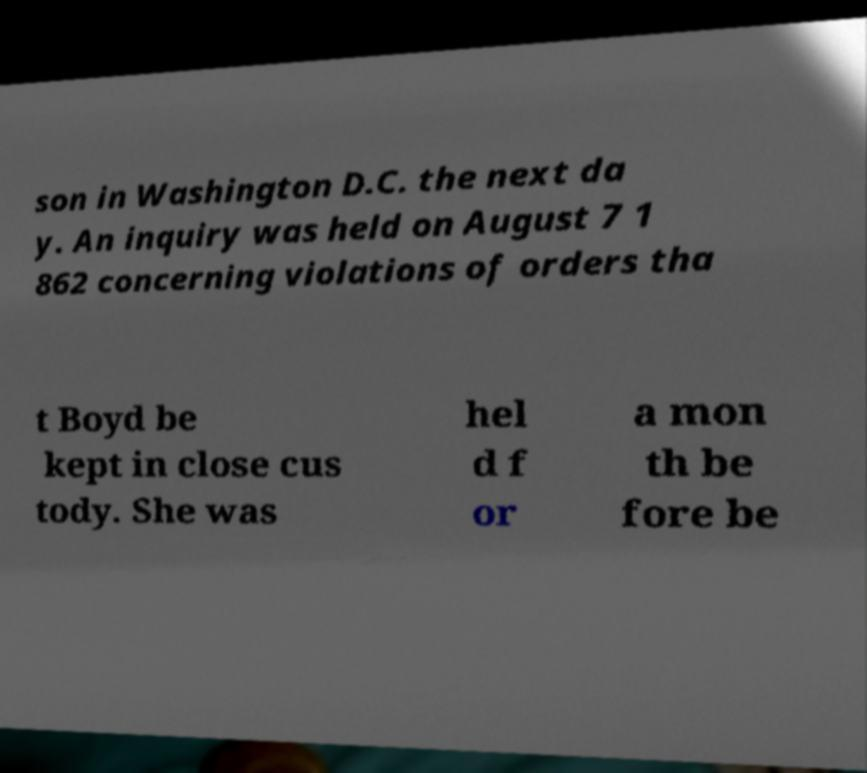There's text embedded in this image that I need extracted. Can you transcribe it verbatim? son in Washington D.C. the next da y. An inquiry was held on August 7 1 862 concerning violations of orders tha t Boyd be kept in close cus tody. She was hel d f or a mon th be fore be 